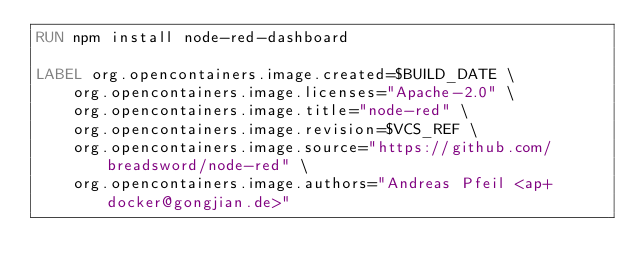<code> <loc_0><loc_0><loc_500><loc_500><_Dockerfile_>RUN npm install node-red-dashboard

LABEL org.opencontainers.image.created=$BUILD_DATE \
    org.opencontainers.image.licenses="Apache-2.0" \
    org.opencontainers.image.title="node-red" \
    org.opencontainers.image.revision=$VCS_REF \
    org.opencontainers.image.source="https://github.com/breadsword/node-red" \
    org.opencontainers.image.authors="Andreas Pfeil <ap+docker@gongjian.de>"
</code> 